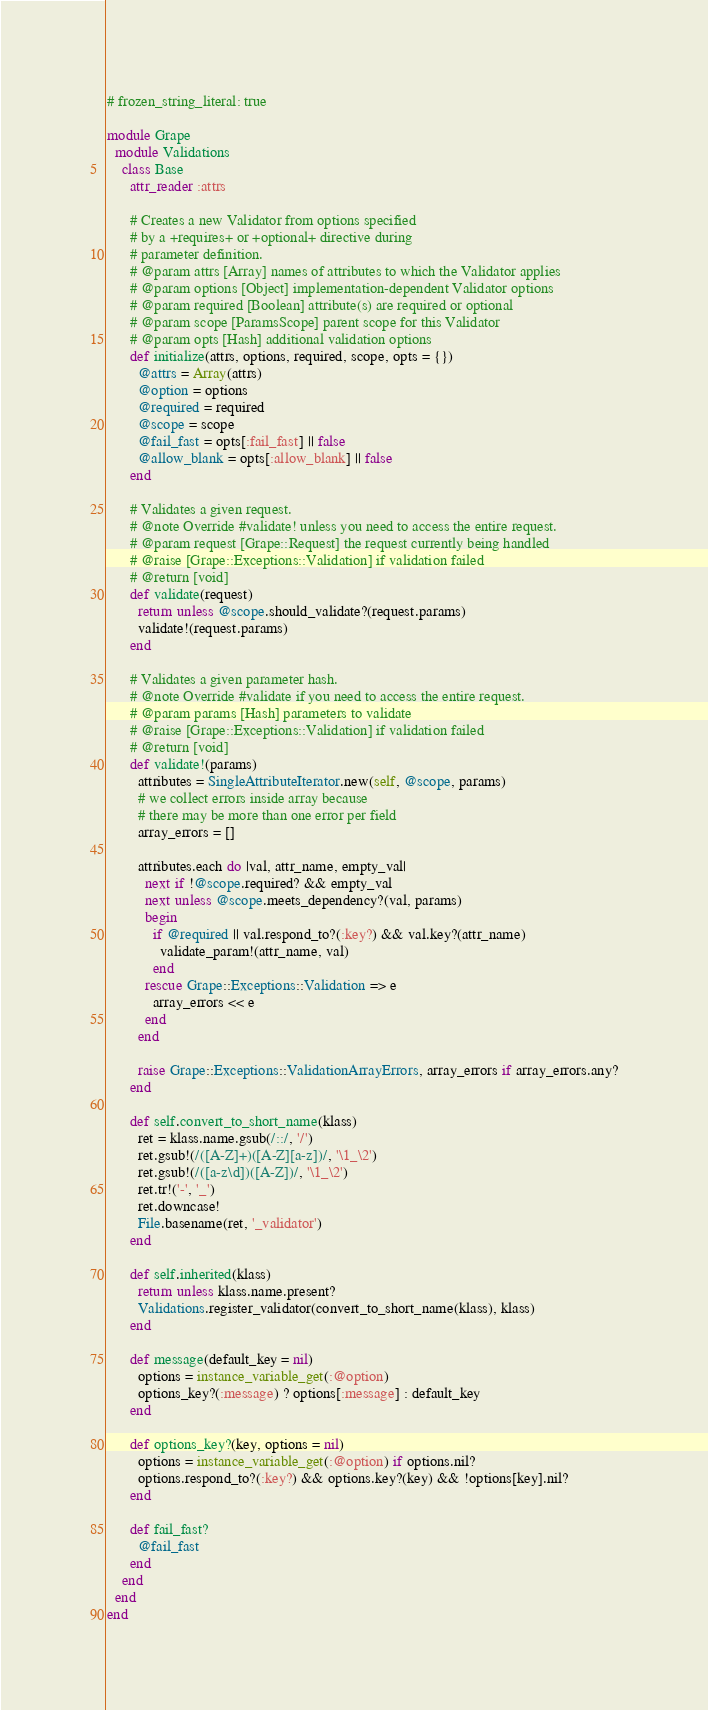Convert code to text. <code><loc_0><loc_0><loc_500><loc_500><_Ruby_># frozen_string_literal: true

module Grape
  module Validations
    class Base
      attr_reader :attrs

      # Creates a new Validator from options specified
      # by a +requires+ or +optional+ directive during
      # parameter definition.
      # @param attrs [Array] names of attributes to which the Validator applies
      # @param options [Object] implementation-dependent Validator options
      # @param required [Boolean] attribute(s) are required or optional
      # @param scope [ParamsScope] parent scope for this Validator
      # @param opts [Hash] additional validation options
      def initialize(attrs, options, required, scope, opts = {})
        @attrs = Array(attrs)
        @option = options
        @required = required
        @scope = scope
        @fail_fast = opts[:fail_fast] || false
        @allow_blank = opts[:allow_blank] || false
      end

      # Validates a given request.
      # @note Override #validate! unless you need to access the entire request.
      # @param request [Grape::Request] the request currently being handled
      # @raise [Grape::Exceptions::Validation] if validation failed
      # @return [void]
      def validate(request)
        return unless @scope.should_validate?(request.params)
        validate!(request.params)
      end

      # Validates a given parameter hash.
      # @note Override #validate if you need to access the entire request.
      # @param params [Hash] parameters to validate
      # @raise [Grape::Exceptions::Validation] if validation failed
      # @return [void]
      def validate!(params)
        attributes = SingleAttributeIterator.new(self, @scope, params)
        # we collect errors inside array because
        # there may be more than one error per field
        array_errors = []

        attributes.each do |val, attr_name, empty_val|
          next if !@scope.required? && empty_val
          next unless @scope.meets_dependency?(val, params)
          begin
            if @required || val.respond_to?(:key?) && val.key?(attr_name)
              validate_param!(attr_name, val)
            end
          rescue Grape::Exceptions::Validation => e
            array_errors << e
          end
        end

        raise Grape::Exceptions::ValidationArrayErrors, array_errors if array_errors.any?
      end

      def self.convert_to_short_name(klass)
        ret = klass.name.gsub(/::/, '/')
        ret.gsub!(/([A-Z]+)([A-Z][a-z])/, '\1_\2')
        ret.gsub!(/([a-z\d])([A-Z])/, '\1_\2')
        ret.tr!('-', '_')
        ret.downcase!
        File.basename(ret, '_validator')
      end

      def self.inherited(klass)
        return unless klass.name.present?
        Validations.register_validator(convert_to_short_name(klass), klass)
      end

      def message(default_key = nil)
        options = instance_variable_get(:@option)
        options_key?(:message) ? options[:message] : default_key
      end

      def options_key?(key, options = nil)
        options = instance_variable_get(:@option) if options.nil?
        options.respond_to?(:key?) && options.key?(key) && !options[key].nil?
      end

      def fail_fast?
        @fail_fast
      end
    end
  end
end
</code> 